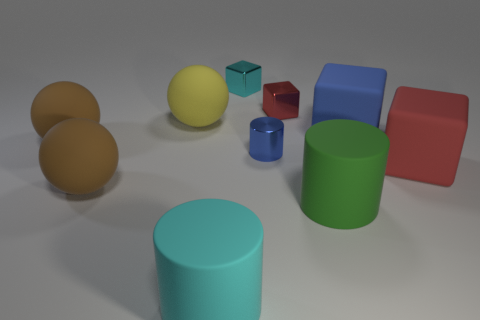What color is the small metallic block that is in front of the tiny block that is behind the red shiny block?
Ensure brevity in your answer.  Red. Does the green matte cylinder have the same size as the cyan shiny block?
Provide a succinct answer. No. Does the block on the right side of the big blue block have the same material as the cube on the left side of the blue cylinder?
Keep it short and to the point. No. There is a cyan object that is in front of the big matte cylinder that is behind the matte cylinder that is left of the tiny cyan thing; what shape is it?
Your response must be concise. Cylinder. Is the number of cyan rubber spheres greater than the number of small cyan shiny cubes?
Keep it short and to the point. No. Is there a tiny cyan shiny thing?
Your response must be concise. Yes. How many things are metallic objects behind the red metallic thing or matte objects in front of the blue matte object?
Give a very brief answer. 6. Is the number of tiny red metallic spheres less than the number of large rubber blocks?
Give a very brief answer. Yes. Are there any big things right of the large yellow object?
Your answer should be very brief. Yes. Is the big cyan object made of the same material as the big blue block?
Provide a short and direct response. Yes. 